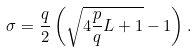<formula> <loc_0><loc_0><loc_500><loc_500>\sigma = \frac { q } { 2 } \left ( \sqrt { 4 \frac { p } { q } L + 1 } - 1 \right ) .</formula> 